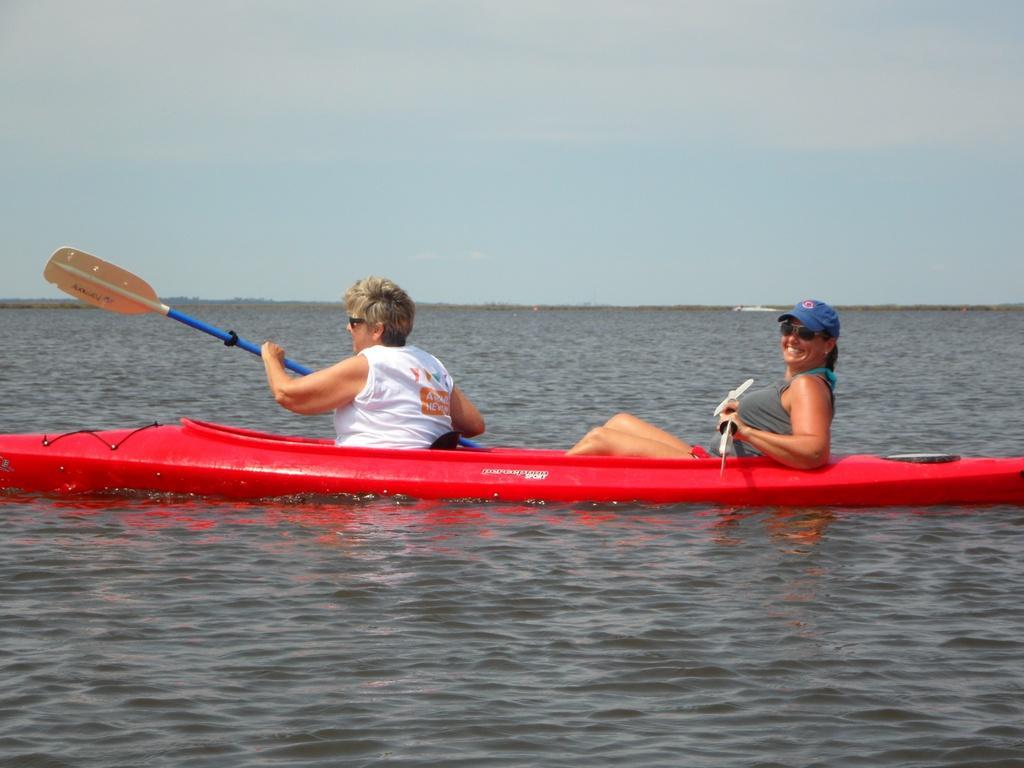In one or two sentences, can you explain what this image depicts? In the center of the image we can see a boat and there are people sitting in the boat. They are holding rows in their hands. At the bottom there is a river. In the background there is sky. 